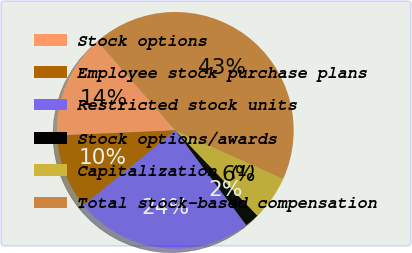Convert chart to OTSL. <chart><loc_0><loc_0><loc_500><loc_500><pie_chart><fcel>Stock options<fcel>Employee stock purchase plans<fcel>Restricted stock units<fcel>Stock options/awards<fcel>Capitalization (1)<fcel>Total stock-based compensation<nl><fcel>14.31%<fcel>10.2%<fcel>24.33%<fcel>1.97%<fcel>6.09%<fcel>43.1%<nl></chart> 